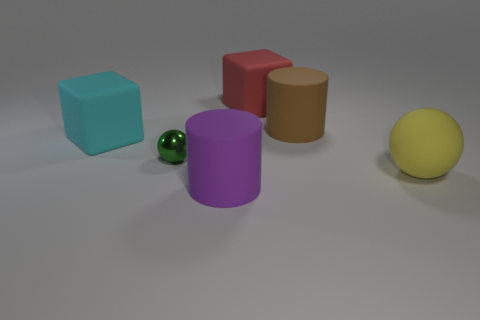Which object in the image appears to be the largest? The red cube seems to be the largest object in the image, given its dimensions in relation to the other shapes. How would you describe the arrangement of the shapes? The objects are arranged in a somewhat scattered manner across the surface, with no apparent pattern to their placement. There's a mix of shapes, including cubes, spheres, and a cylinder, offering a variety of geometrical forms to observe. 